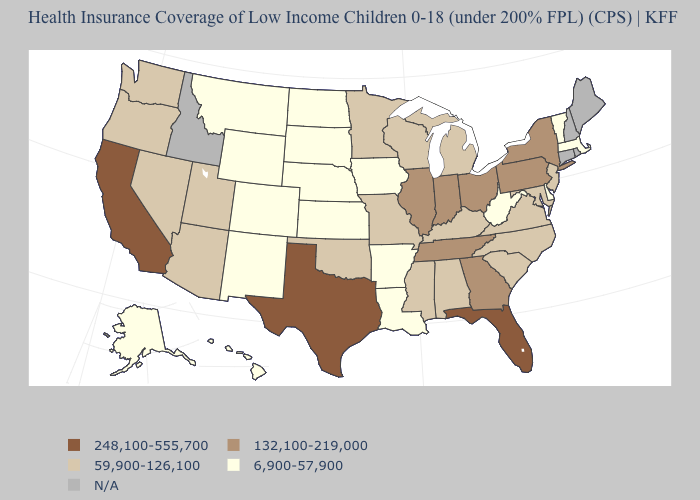Which states hav the highest value in the MidWest?
Short answer required. Illinois, Indiana, Ohio. What is the lowest value in the USA?
Answer briefly. 6,900-57,900. Among the states that border Maryland , which have the lowest value?
Short answer required. Delaware, West Virginia. What is the value of North Dakota?
Concise answer only. 6,900-57,900. Which states have the highest value in the USA?
Answer briefly. California, Florida, Texas. How many symbols are there in the legend?
Give a very brief answer. 5. What is the value of Delaware?
Short answer required. 6,900-57,900. What is the highest value in the USA?
Concise answer only. 248,100-555,700. How many symbols are there in the legend?
Quick response, please. 5. What is the value of California?
Give a very brief answer. 248,100-555,700. What is the lowest value in states that border Tennessee?
Keep it brief. 6,900-57,900. Does Mississippi have the highest value in the USA?
Quick response, please. No. What is the highest value in the USA?
Be succinct. 248,100-555,700. How many symbols are there in the legend?
Keep it brief. 5. Is the legend a continuous bar?
Concise answer only. No. 